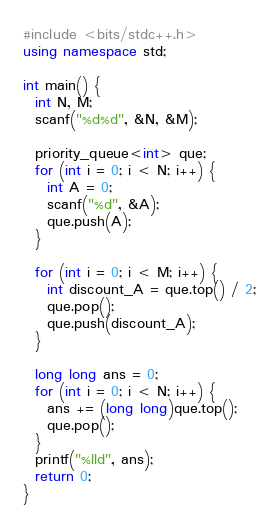Convert code to text. <code><loc_0><loc_0><loc_500><loc_500><_C++_>#include <bits/stdc++.h>
using namespace std;

int main() {
  int N, M;
  scanf("%d%d", &N, &M);

  priority_queue<int> que;
  for (int i = 0; i < N; i++) {
    int A = 0;
    scanf("%d", &A);
    que.push(A);
  }

  for (int i = 0; i < M; i++) {
    int discount_A = que.top() / 2;
    que.pop();
    que.push(discount_A);
  }

  long long ans = 0;
  for (int i = 0; i < N; i++) {
    ans += (long long)que.top();
    que.pop();
  }
  printf("%lld", ans);
  return 0;
}
</code> 